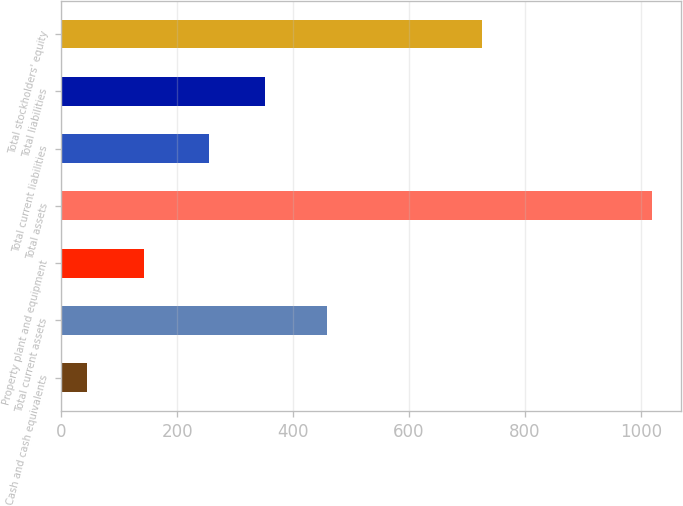Convert chart to OTSL. <chart><loc_0><loc_0><loc_500><loc_500><bar_chart><fcel>Cash and cash equivalents<fcel>Total current assets<fcel>Property plant and equipment<fcel>Total assets<fcel>Total current liabilities<fcel>Total liabilities<fcel>Total stockholders' equity<nl><fcel>44.6<fcel>458.7<fcel>141.97<fcel>1018.3<fcel>254.6<fcel>351.97<fcel>725.5<nl></chart> 